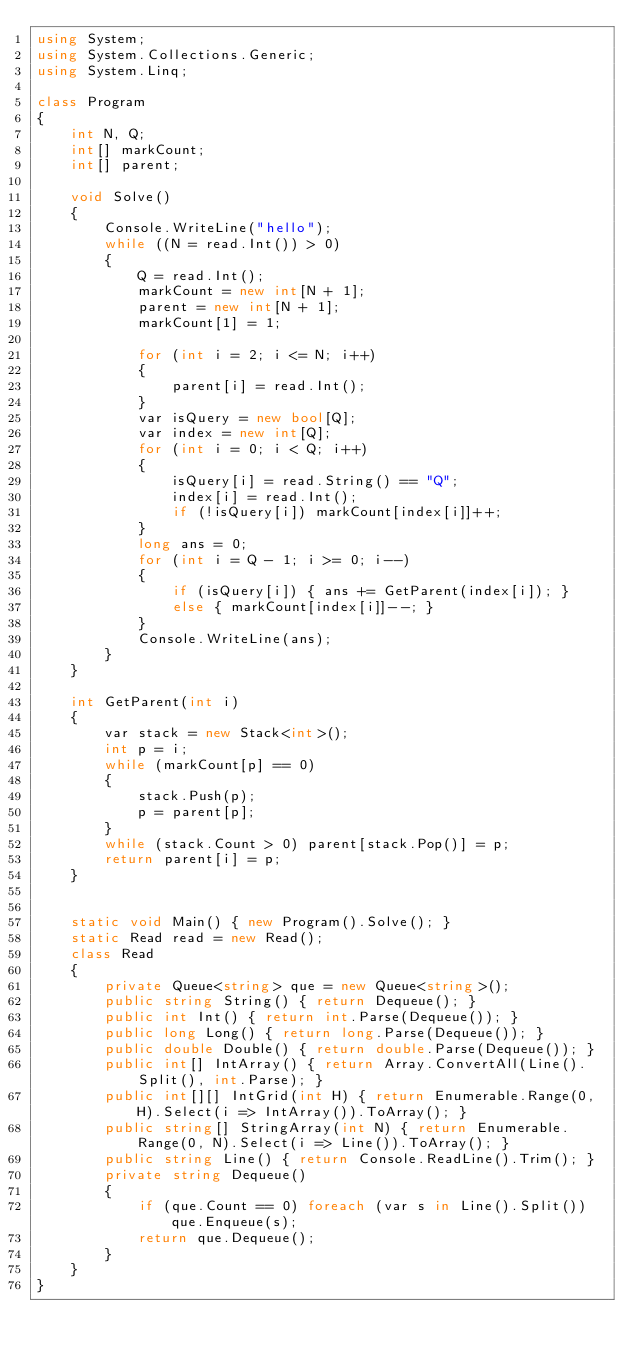<code> <loc_0><loc_0><loc_500><loc_500><_C#_>using System;
using System.Collections.Generic;
using System.Linq;

class Program
{
    int N, Q;
    int[] markCount;
    int[] parent;

    void Solve()
    {
        Console.WriteLine("hello");
        while ((N = read.Int()) > 0)
        {
            Q = read.Int();
            markCount = new int[N + 1];
            parent = new int[N + 1];
            markCount[1] = 1;

            for (int i = 2; i <= N; i++)
            {
                parent[i] = read.Int();
            }
            var isQuery = new bool[Q];
            var index = new int[Q];
            for (int i = 0; i < Q; i++)
            {
                isQuery[i] = read.String() == "Q";
                index[i] = read.Int();
                if (!isQuery[i]) markCount[index[i]]++;
            }
            long ans = 0;
            for (int i = Q - 1; i >= 0; i--)
            {
                if (isQuery[i]) { ans += GetParent(index[i]); }
                else { markCount[index[i]]--; }
            }
            Console.WriteLine(ans);
        }
    }

    int GetParent(int i)
    {
        var stack = new Stack<int>();
        int p = i;
        while (markCount[p] == 0)
        {
            stack.Push(p);
            p = parent[p];
        }
        while (stack.Count > 0) parent[stack.Pop()] = p;
        return parent[i] = p;
    }


    static void Main() { new Program().Solve(); }
    static Read read = new Read();
    class Read
    {
        private Queue<string> que = new Queue<string>();
        public string String() { return Dequeue(); }
        public int Int() { return int.Parse(Dequeue()); }
        public long Long() { return long.Parse(Dequeue()); }
        public double Double() { return double.Parse(Dequeue()); }
        public int[] IntArray() { return Array.ConvertAll(Line().Split(), int.Parse); }
        public int[][] IntGrid(int H) { return Enumerable.Range(0, H).Select(i => IntArray()).ToArray(); }
        public string[] StringArray(int N) { return Enumerable.Range(0, N).Select(i => Line()).ToArray(); }
        public string Line() { return Console.ReadLine().Trim(); }
        private string Dequeue()
        {
            if (que.Count == 0) foreach (var s in Line().Split()) que.Enqueue(s);
            return que.Dequeue();
        }
    }
}</code> 